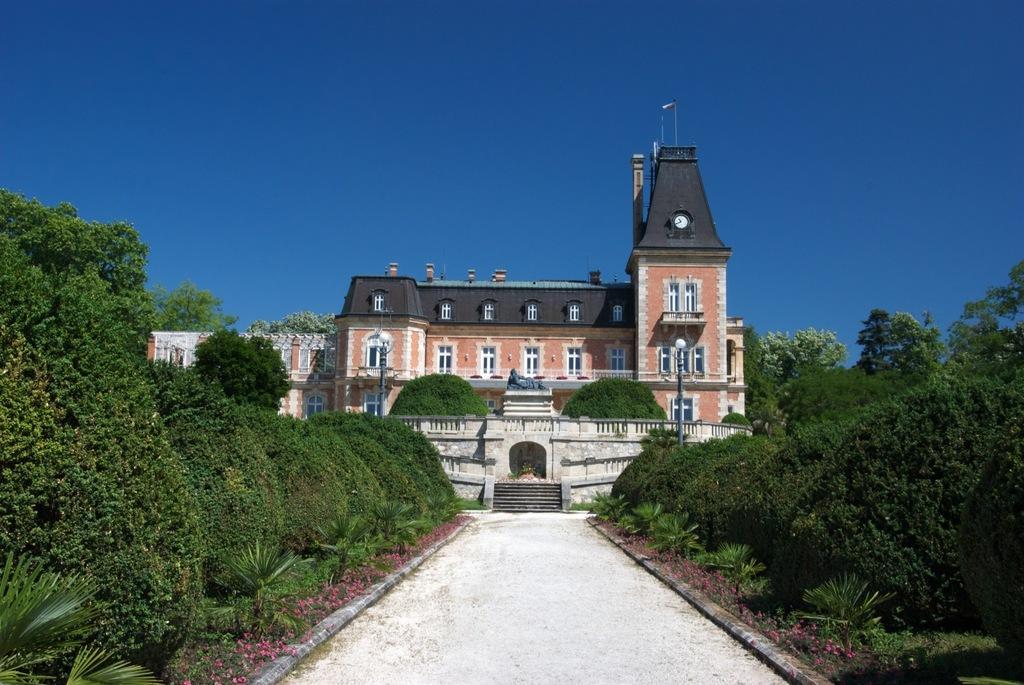Can you describe this image briefly? In this image there is the sky, there is a building, there are windows, there is a streetlight, there is a pole, there are trees truncated towards the right of the image, there are trees truncated towards the left of the image, there are flowers, there are staircase. 